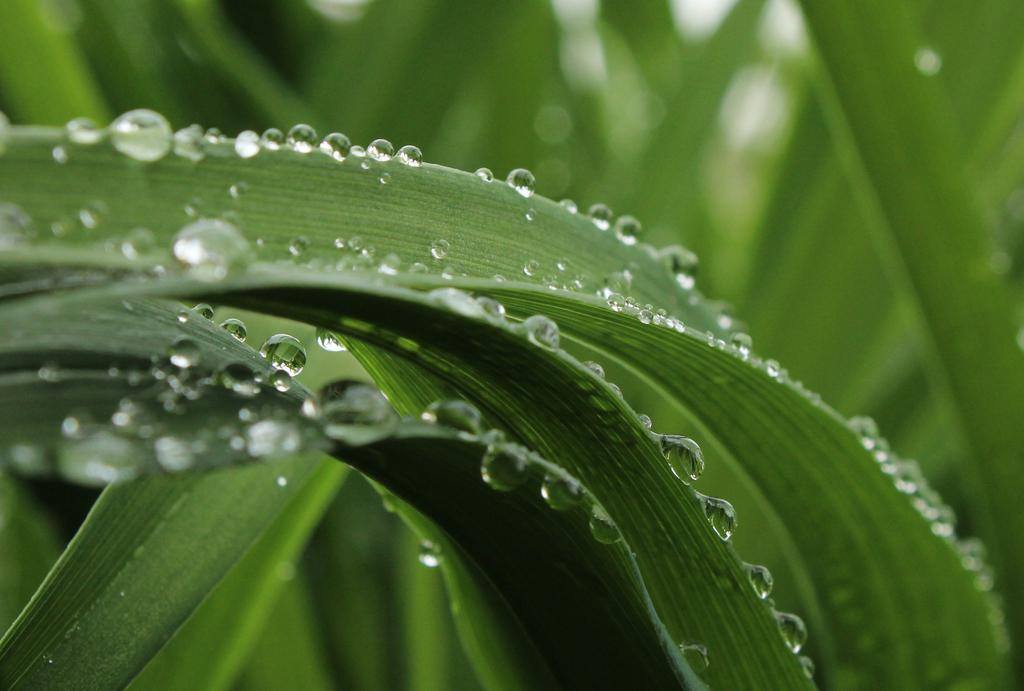What type of natural elements can be seen in the image? There are leaves in the image. What is the condition of the leaves? The leaves have water droplets on them. Can you describe the background of the image? The background of the image is blurred. What type of advice does the governor give to the doctor in the image? There is no governor, doctor, or any form of interaction present in the image. The image only features leaves with water droplets and a blurred background. 